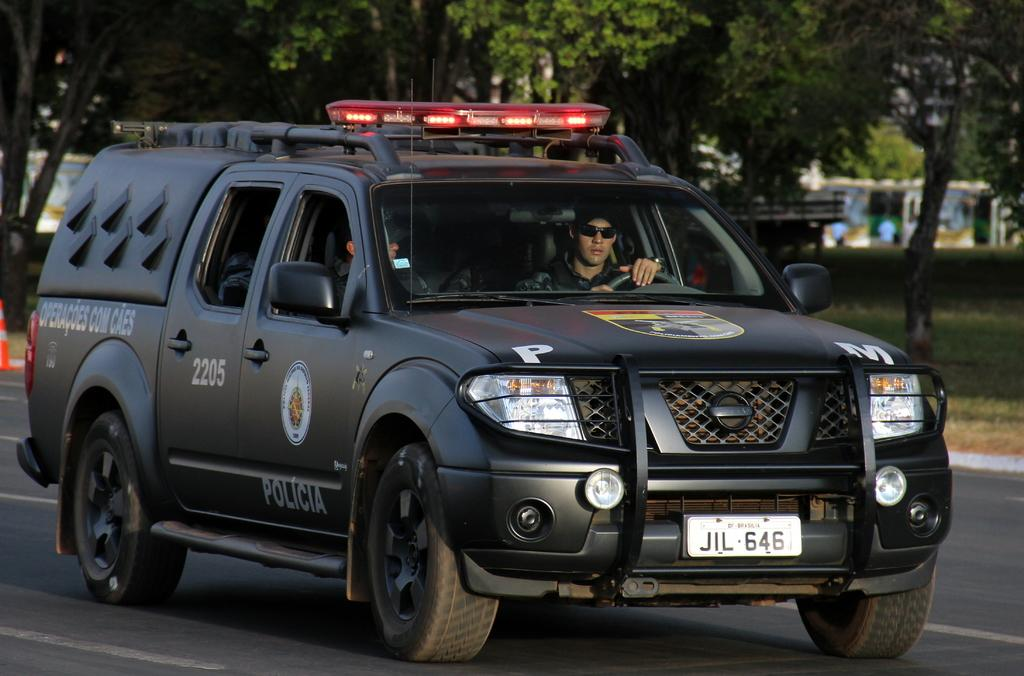What type of car is in the image? There is a black car in the image, and it is a police vehicle. How many people are inside the car? There are two persons in the car. What is visible at the bottom of the image? There is a road at the bottom of the image. What can be seen in the background of the image? There are trees in the background of the image. What riddle is being solved by the persons in the car? There is no indication in the image that the persons in the car are solving a riddle. How many seats are available in the car? The image does not show the interior of the car, so it is impossible to determine the number of seats. 